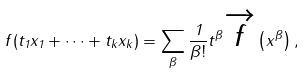<formula> <loc_0><loc_0><loc_500><loc_500>f ( t _ { 1 } x _ { 1 } + \dots + t _ { k } x _ { k } ) = \sum _ { \beta } \frac { 1 } { \beta ! } t ^ { \beta } \overrightarrow { f } \left ( x ^ { \beta } \right ) ,</formula> 